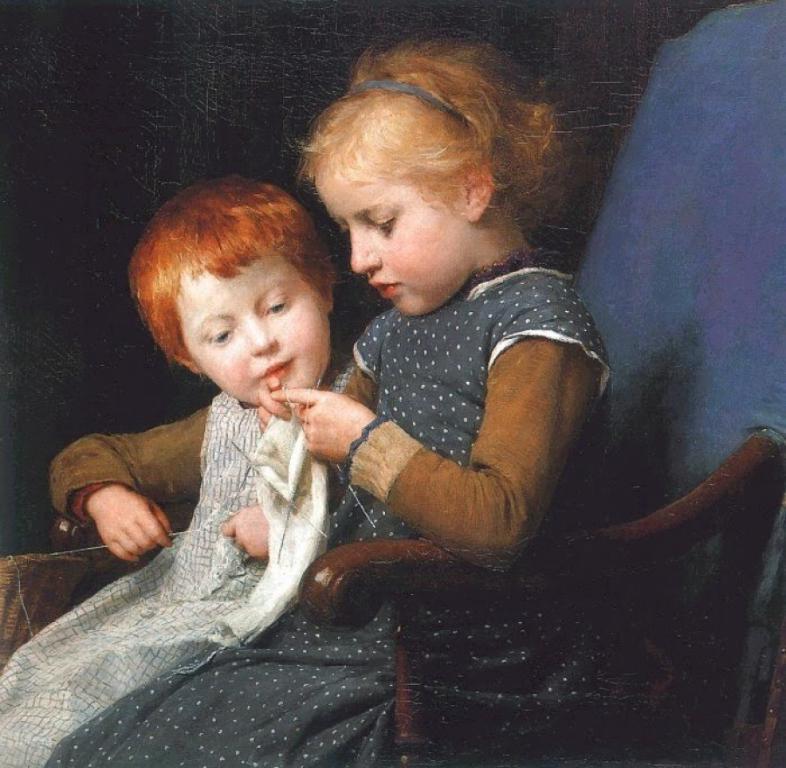Can you describe this image briefly? In this image we can see that two kids are sitting in a chair. In the background of the image there is a dark background. 